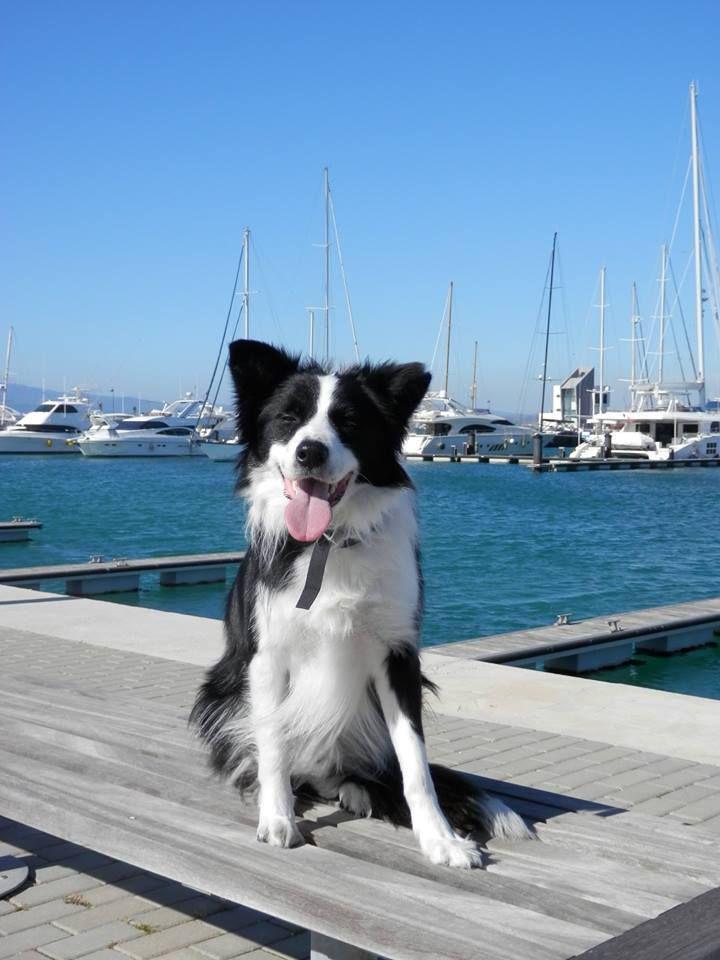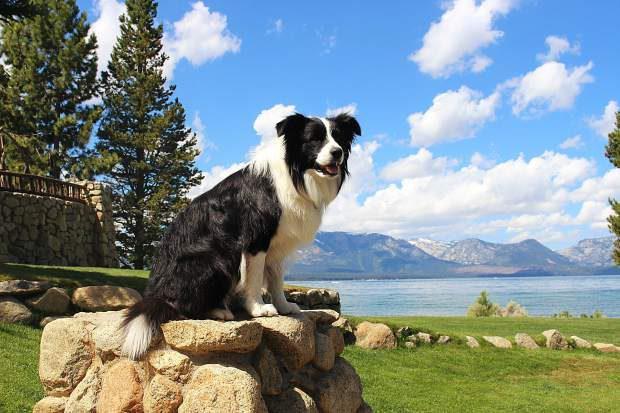The first image is the image on the left, the second image is the image on the right. Given the left and right images, does the statement "Exactly one dog is sitting." hold true? Answer yes or no. No. 